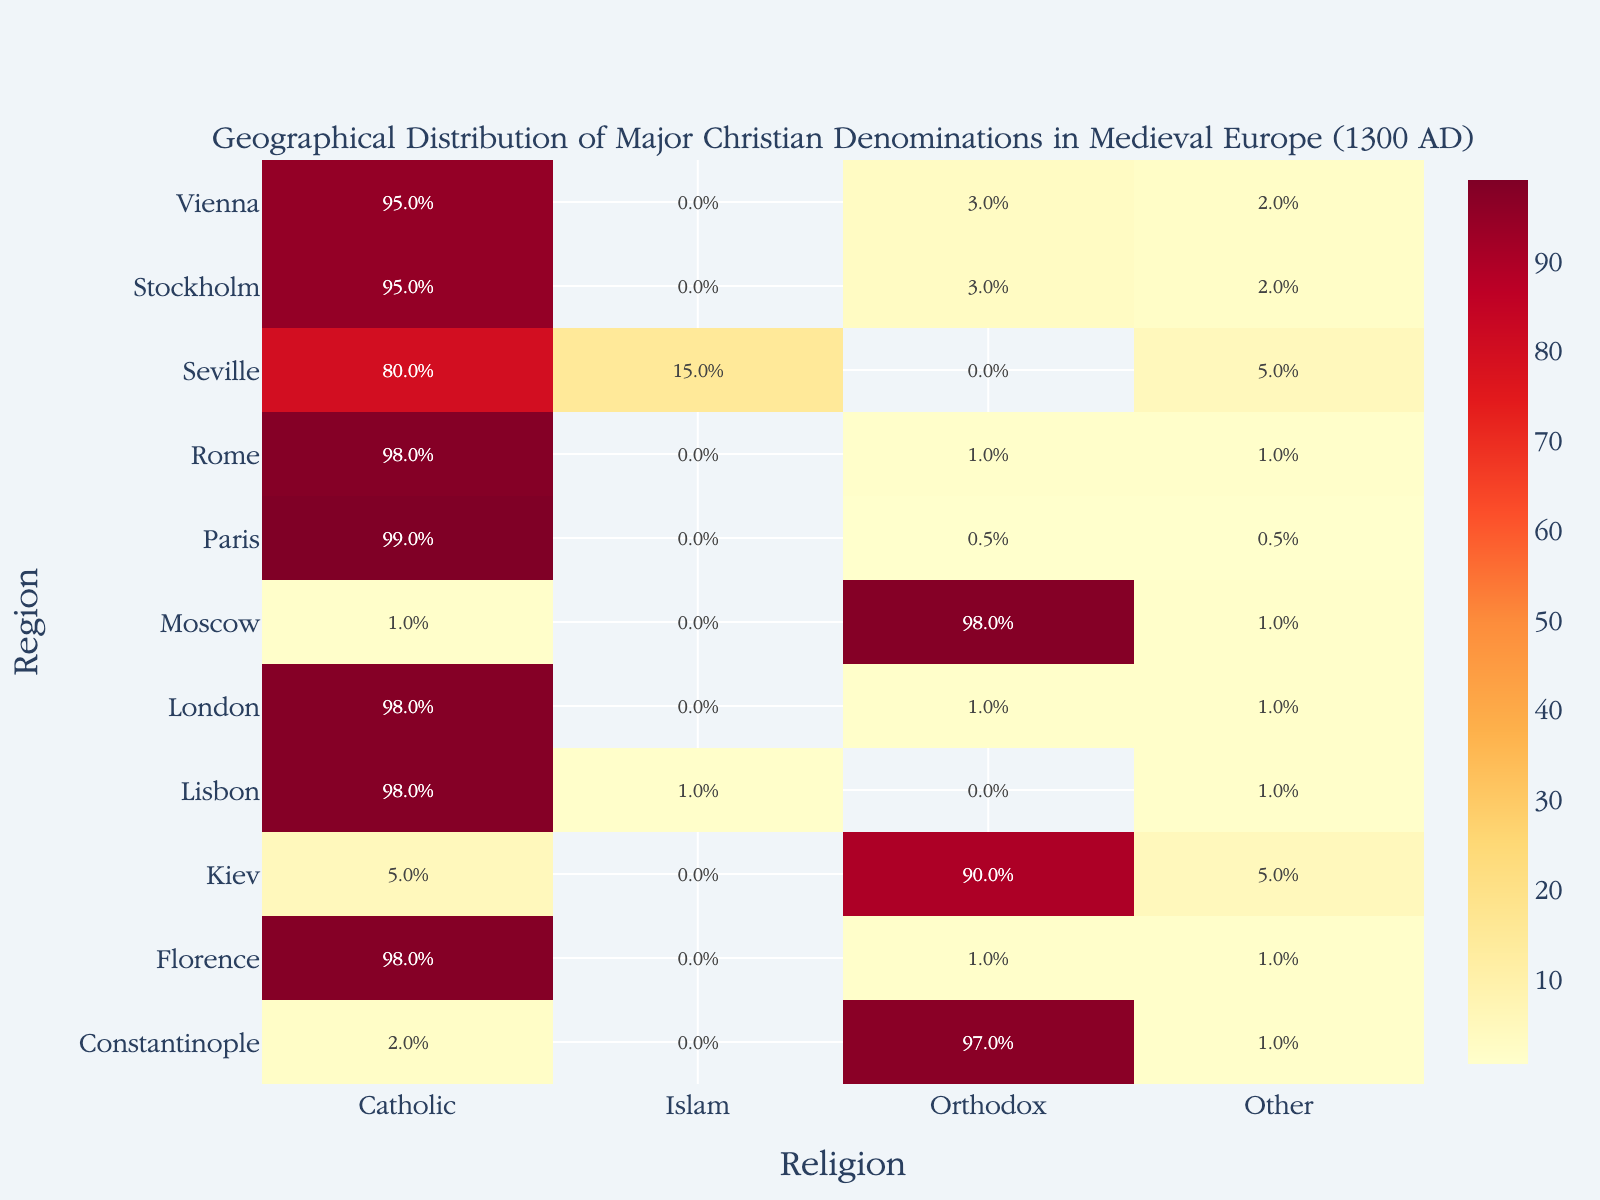Which region has the highest percentage of Orthodox Christians? By observing the regions in the heatmap and looking at the percentage values for Orthodox Christians, it is evident that Moscow has the highest percentage with 98%.
Answer: Moscow What is the main denomination in Seville, 1300? By looking at the heatmap, we can see the most significant portion of Seville in 1300 is covered by Catholicism with an 80% representation.
Answer: Catholicism Which region shows a substantial presence of Islam? Seville has 15% of its population practicing Islam, which is the most substantial among all listed regions in Medieval Europe.
Answer: Seville How does the percentage of Orthodox Christians in Kiev compare to that in Constantinople? From the heatmap, the percentage of Orthodox Christians in Kiev is 90%, while in Constantinople, it is 97%. This shows that Constantinople has a higher percentage of Orthodox Christians compared to Kiev.
Answer: Constantinople has a higher percentage What are the combined percentages of 'Other' religions in Vienna and Florence? According to the heatmap, Vienna has 2% and Florence has 1% representation under 'Other'. Thus, combined, it is 2% + 1% = 3%.
Answer: 3% What proportion of Christians (Catholic and Orthodox) is there in Stockholm? In Stockholm, there are 95% Catholics and 3% Orthodox, thus the total percentage of Christians are 95% + 3% = 98%.
Answer: 98% Which regions have exactly 1% of 'Other' religions? By inspecting the heatmap, the regions Rome, Constantinople, London, Florence, Lisbon have 1% of their religious distribution marked as 'Other'.
Answer: Rome, Constantinople, London, Florence, Lisbon Compare the percentage of Catholics between Paris and Vienna. The heatmap shows that Paris has 99% Catholics whereas Vienna has 95%. Therefore, Paris has a higher percentage of Catholics compared to Vienna.
Answer: Paris has a higher percentage What is the least common religion in Constantinople, 1300? According to the heatmap, 'Other' religion has the lowest percentage at 1% in Constantinople in 1300.
Answer: Other How much higher is the percentage of Orthodox Christians in Moscow compared to Rome? The heatmap shows Moscow has 98% Orthodox Christians and Rome has 1%. The difference thus is 98% - 1% = 97%.
Answer: 97% higher 